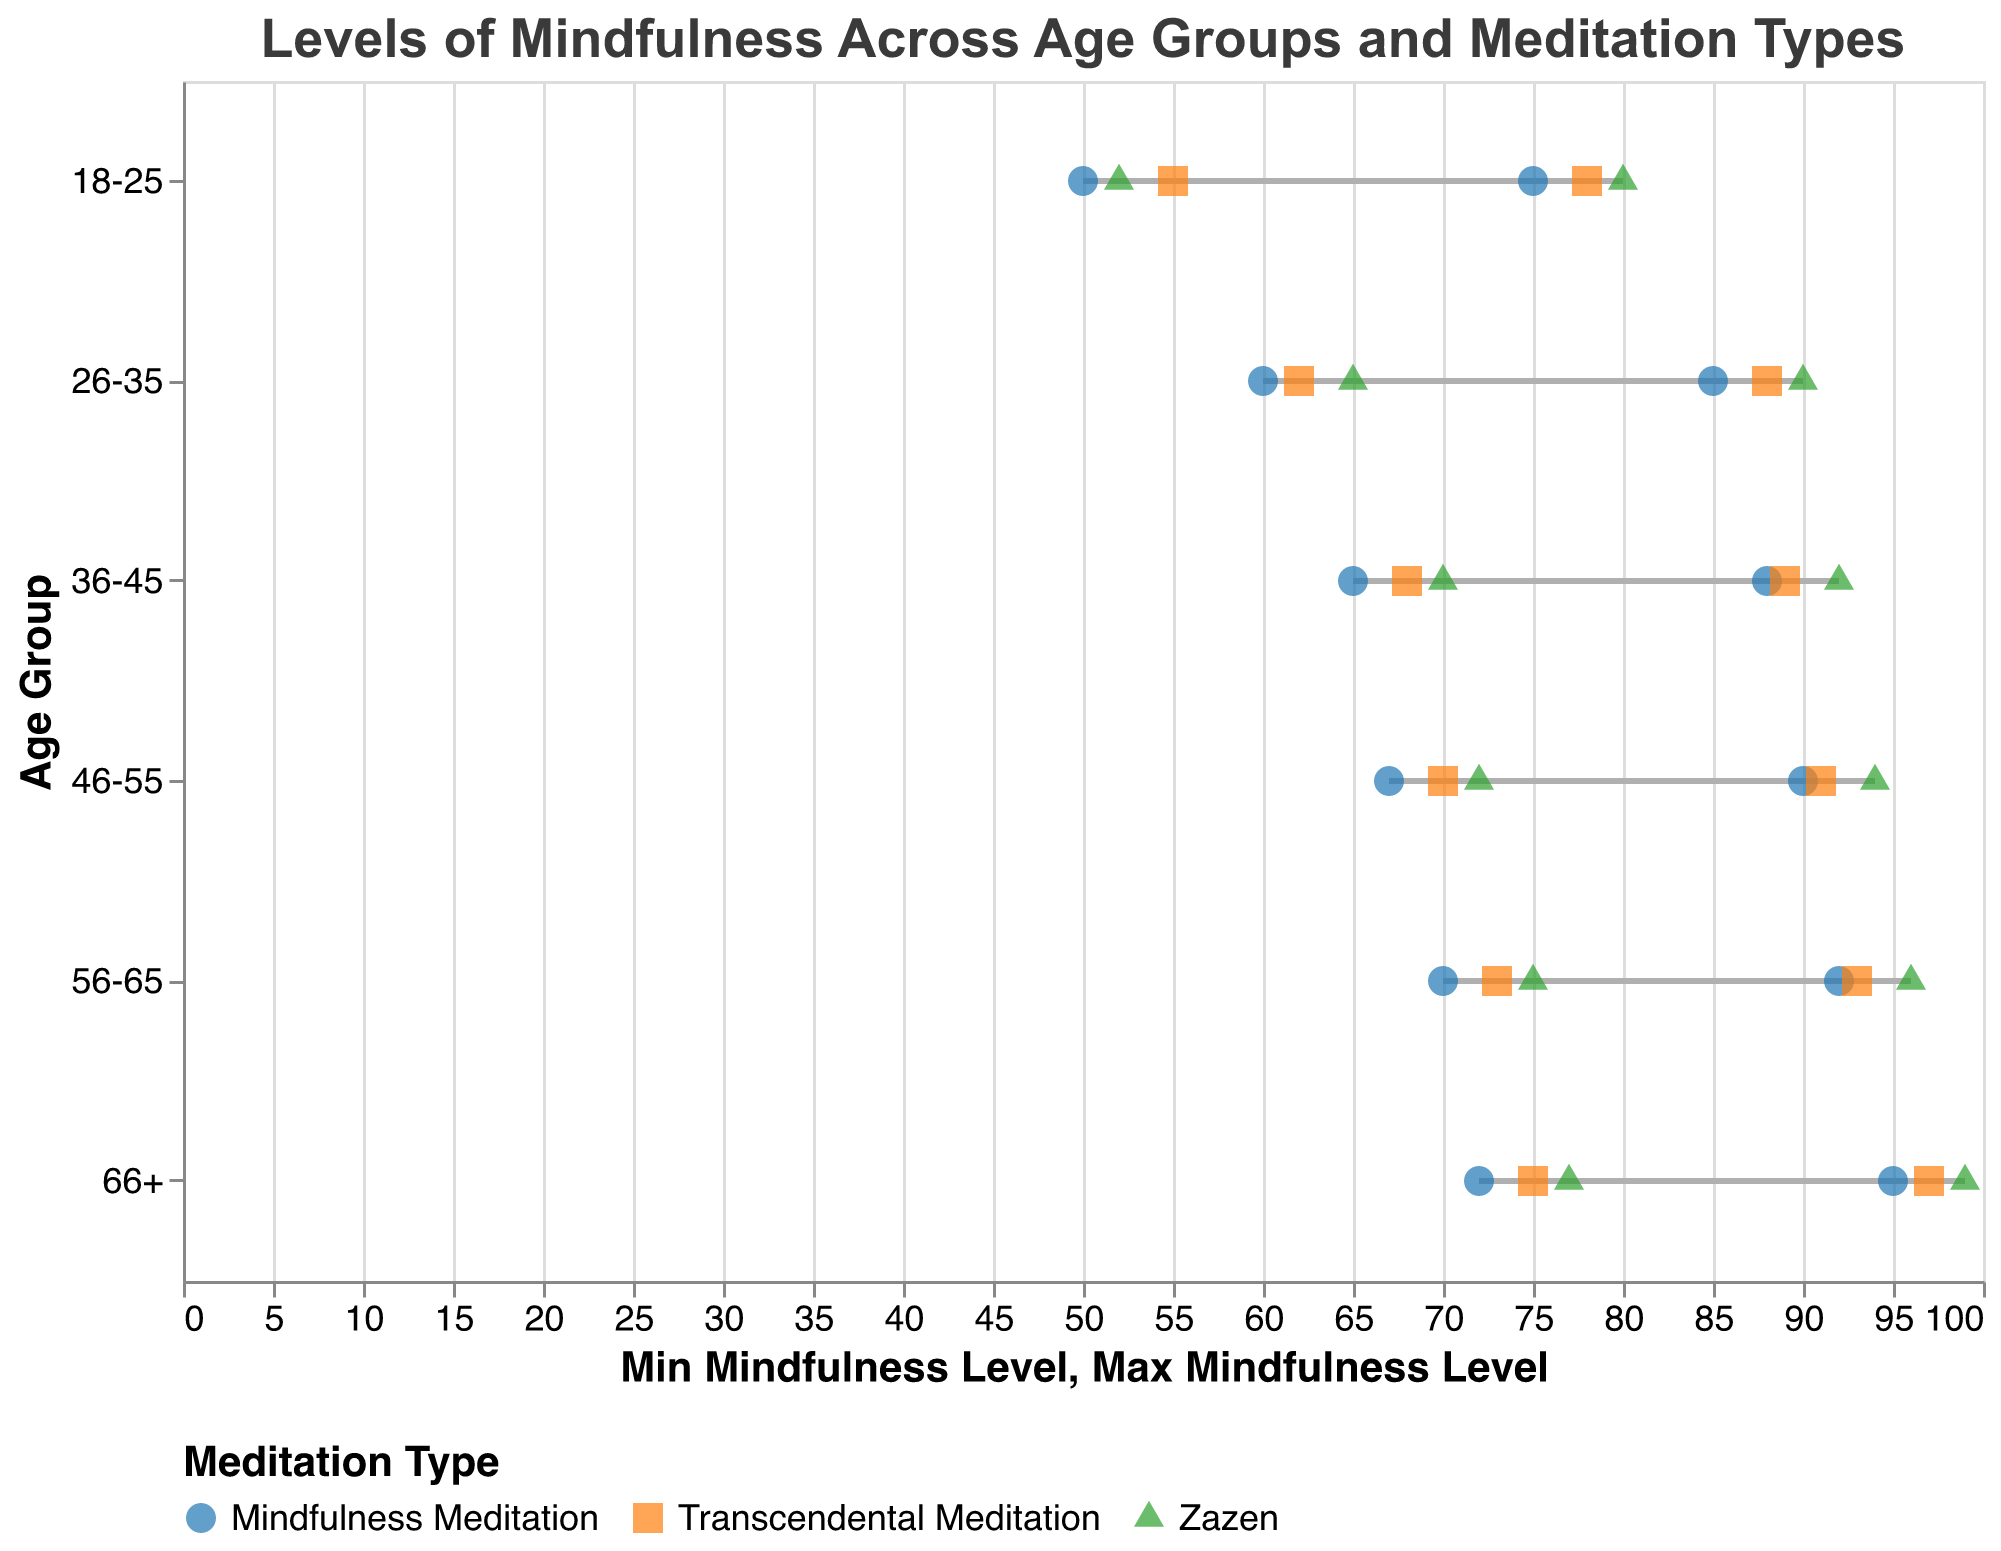What is the minimum mindfulness level for the age group 18-25 practicing Mindfulness Meditation? Look at the "18-25" age group row and find the column for "Mindfulness Meditation". The minimum mindfulness level value is listed there.
Answer: 50 What are the age groups represented in the plot? Examine the y-axis to see all the age groups listed as labels.
Answer: 18-25, 26-35, 36-45, 46-55, 56-65, 66+ What type of meditation has the highest maximum mindfulness level for the 66+ age group? Find the row for 66+ age group and then look at the "Max Mindfulness Level" column for each type of meditation to identify the highest value.
Answer: Zazen Which age group has the widest range of mindfulness levels practicing Transcendental Meditation? Calculate the difference between the minimum and maximum mindfulness levels for Transcendental Meditation in each age group. The age group with the largest difference has the widest range.
Answer: 66+ What is the color associated with Zazen in the plot? Look at the legend to find the color that represents Zazen.
Answer: Green How does the minimum mindfulness level for Zazen in the 18-25 age group compare to that of Transcendental Meditation in the same age group? Check the minimum mindfulness levels for Zazen and Transcendental Meditation within the 18-25 age group. Compare these two values.
Answer: Zazen is 3 units lower than Transcendental Meditation Which type of meditation shows a continuous increase in minimum mindfulness levels across all age groups? Check the minimum mindfulness levels for each type of meditation across all age groups to see which one has consistently increasing levels.
Answer: Zazen For the 36-45 age group, what is the difference between the maximum mindfulness levels of Mindfulness Meditation and Zazen? Find the maximum mindfulness levels for both Mindfulness Meditation and Zazen in the 36-45 age group and calculate the difference.
Answer: 4 What is the average maximum mindfulness level for the 46-55 age group across all types of meditation? Sum the maximum mindfulness levels for all types of meditation in the 46-55 age group and divide by the number of types (3 in this case).
Answer: 91.67 Which age group and type of meditation combination has the smallest range of mindfulness levels? Calculate the range (difference between max and min levels) for each age group and meditation type combination. Identify the smallest range.
Answer: 18-25 and Mindfulness Meditation 